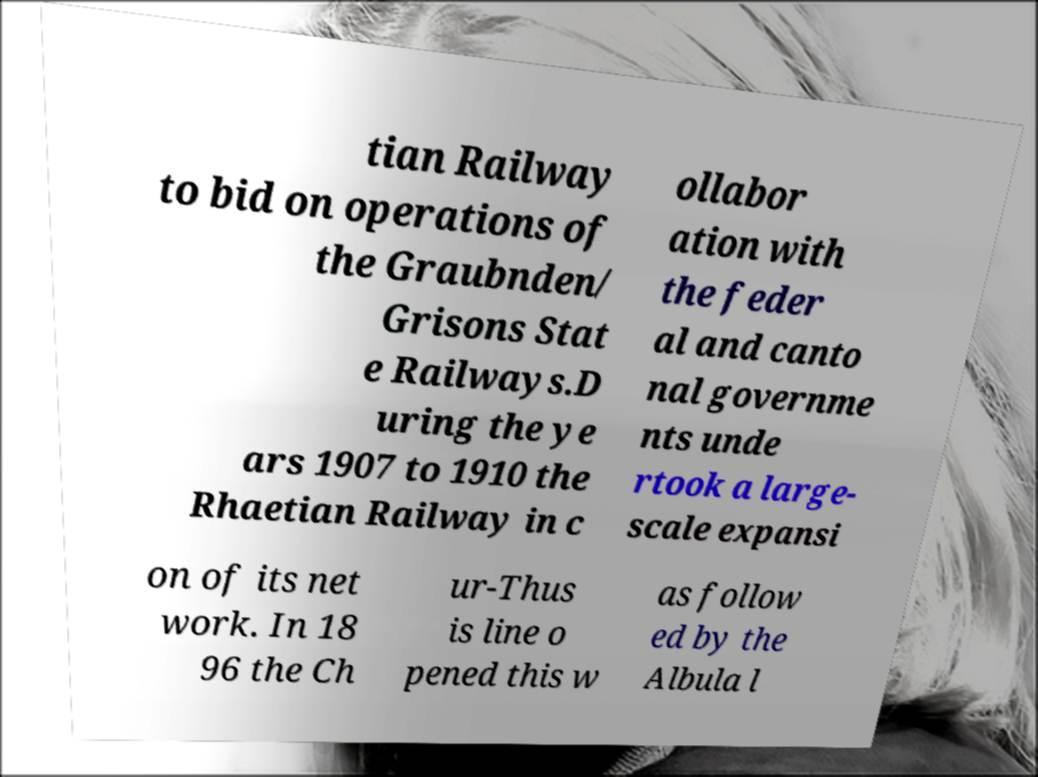Please read and relay the text visible in this image. What does it say? tian Railway to bid on operations of the Graubnden/ Grisons Stat e Railways.D uring the ye ars 1907 to 1910 the Rhaetian Railway in c ollabor ation with the feder al and canto nal governme nts unde rtook a large- scale expansi on of its net work. In 18 96 the Ch ur-Thus is line o pened this w as follow ed by the Albula l 